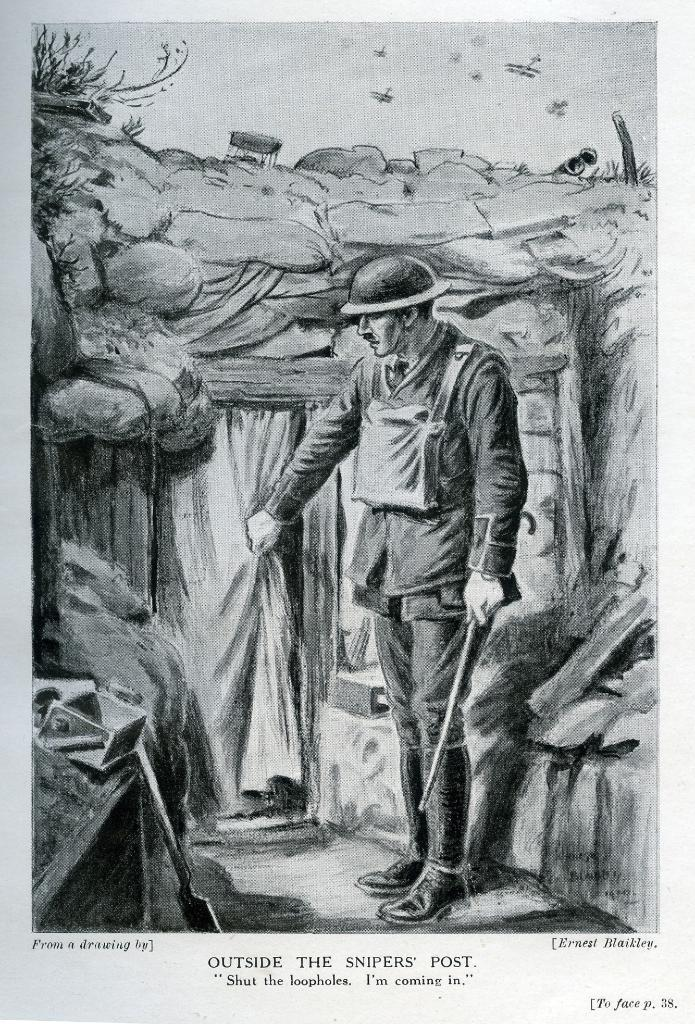What is the main subject of the image? There is a portrait of a man in the image. What is the man wearing in the portrait? The man is dressed in a uniform. What action is the man performing in the image? The man is opening a door. What can be seen in the background of the image? There are trees in the background of the image. What type of party is being held in the background of the image? There is no party present in the image; it features a portrait of a man opening a door with trees in the background. How many rabbits can be seen in the image? There are no rabbits present in the image. 